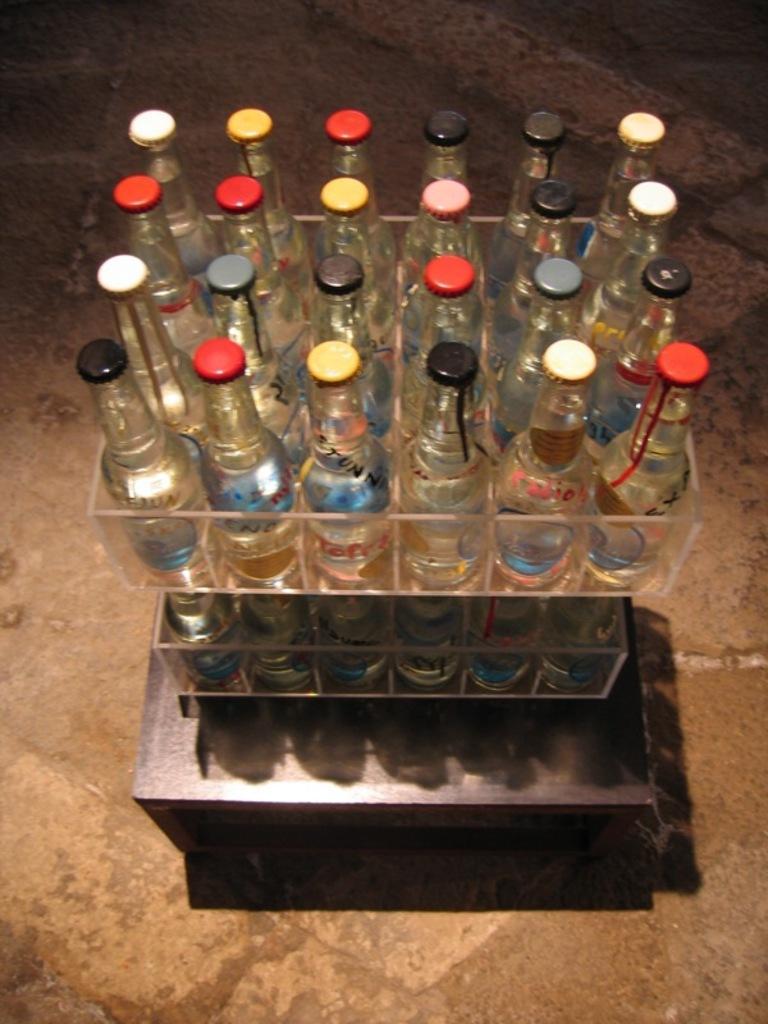How would you summarize this image in a sentence or two? In this image there are group of bottles, which are kept in a box and the box is kept on a wooden table, which is on the floor. The bottles have different color lids to each of them. 